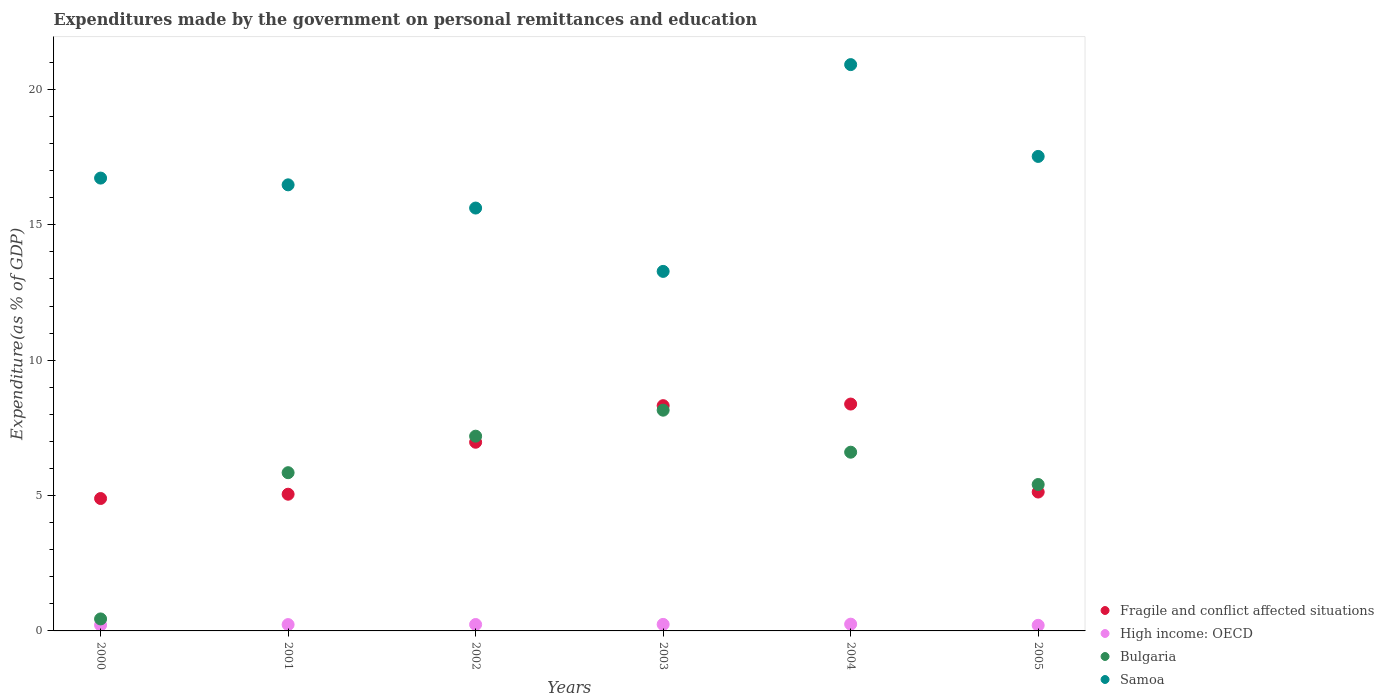Is the number of dotlines equal to the number of legend labels?
Make the answer very short. Yes. What is the expenditures made by the government on personal remittances and education in High income: OECD in 2001?
Ensure brevity in your answer.  0.23. Across all years, what is the maximum expenditures made by the government on personal remittances and education in Samoa?
Make the answer very short. 20.92. Across all years, what is the minimum expenditures made by the government on personal remittances and education in Samoa?
Your response must be concise. 13.28. In which year was the expenditures made by the government on personal remittances and education in High income: OECD maximum?
Ensure brevity in your answer.  2004. In which year was the expenditures made by the government on personal remittances and education in Bulgaria minimum?
Make the answer very short. 2000. What is the total expenditures made by the government on personal remittances and education in Bulgaria in the graph?
Offer a terse response. 33.65. What is the difference between the expenditures made by the government on personal remittances and education in Bulgaria in 2000 and that in 2005?
Your answer should be very brief. -4.97. What is the difference between the expenditures made by the government on personal remittances and education in Samoa in 2004 and the expenditures made by the government on personal remittances and education in High income: OECD in 2005?
Provide a succinct answer. 20.71. What is the average expenditures made by the government on personal remittances and education in Fragile and conflict affected situations per year?
Provide a short and direct response. 6.46. In the year 2000, what is the difference between the expenditures made by the government on personal remittances and education in Bulgaria and expenditures made by the government on personal remittances and education in High income: OECD?
Keep it short and to the point. 0.23. In how many years, is the expenditures made by the government on personal remittances and education in Samoa greater than 17 %?
Offer a very short reply. 2. What is the ratio of the expenditures made by the government on personal remittances and education in Samoa in 2001 to that in 2004?
Your answer should be compact. 0.79. Is the difference between the expenditures made by the government on personal remittances and education in Bulgaria in 2003 and 2005 greater than the difference between the expenditures made by the government on personal remittances and education in High income: OECD in 2003 and 2005?
Keep it short and to the point. Yes. What is the difference between the highest and the second highest expenditures made by the government on personal remittances and education in High income: OECD?
Give a very brief answer. 0.01. What is the difference between the highest and the lowest expenditures made by the government on personal remittances and education in High income: OECD?
Provide a short and direct response. 0.04. In how many years, is the expenditures made by the government on personal remittances and education in High income: OECD greater than the average expenditures made by the government on personal remittances and education in High income: OECD taken over all years?
Your answer should be compact. 4. Is the sum of the expenditures made by the government on personal remittances and education in Fragile and conflict affected situations in 2000 and 2002 greater than the maximum expenditures made by the government on personal remittances and education in Bulgaria across all years?
Ensure brevity in your answer.  Yes. Is it the case that in every year, the sum of the expenditures made by the government on personal remittances and education in High income: OECD and expenditures made by the government on personal remittances and education in Bulgaria  is greater than the expenditures made by the government on personal remittances and education in Samoa?
Make the answer very short. No. Is the expenditures made by the government on personal remittances and education in Samoa strictly less than the expenditures made by the government on personal remittances and education in Fragile and conflict affected situations over the years?
Provide a succinct answer. No. How many years are there in the graph?
Keep it short and to the point. 6. Are the values on the major ticks of Y-axis written in scientific E-notation?
Provide a short and direct response. No. Does the graph contain any zero values?
Your answer should be very brief. No. Does the graph contain grids?
Give a very brief answer. No. How many legend labels are there?
Provide a short and direct response. 4. What is the title of the graph?
Offer a terse response. Expenditures made by the government on personal remittances and education. What is the label or title of the Y-axis?
Provide a succinct answer. Expenditure(as % of GDP). What is the Expenditure(as % of GDP) of Fragile and conflict affected situations in 2000?
Provide a succinct answer. 4.89. What is the Expenditure(as % of GDP) in High income: OECD in 2000?
Your answer should be compact. 0.22. What is the Expenditure(as % of GDP) in Bulgaria in 2000?
Your answer should be compact. 0.44. What is the Expenditure(as % of GDP) of Samoa in 2000?
Your answer should be compact. 16.73. What is the Expenditure(as % of GDP) in Fragile and conflict affected situations in 2001?
Offer a very short reply. 5.05. What is the Expenditure(as % of GDP) of High income: OECD in 2001?
Provide a succinct answer. 0.23. What is the Expenditure(as % of GDP) of Bulgaria in 2001?
Provide a short and direct response. 5.84. What is the Expenditure(as % of GDP) of Samoa in 2001?
Offer a very short reply. 16.48. What is the Expenditure(as % of GDP) in Fragile and conflict affected situations in 2002?
Ensure brevity in your answer.  6.97. What is the Expenditure(as % of GDP) in High income: OECD in 2002?
Make the answer very short. 0.24. What is the Expenditure(as % of GDP) in Bulgaria in 2002?
Provide a short and direct response. 7.19. What is the Expenditure(as % of GDP) in Samoa in 2002?
Your response must be concise. 15.62. What is the Expenditure(as % of GDP) in Fragile and conflict affected situations in 2003?
Offer a terse response. 8.32. What is the Expenditure(as % of GDP) of High income: OECD in 2003?
Offer a very short reply. 0.24. What is the Expenditure(as % of GDP) in Bulgaria in 2003?
Give a very brief answer. 8.15. What is the Expenditure(as % of GDP) in Samoa in 2003?
Provide a short and direct response. 13.28. What is the Expenditure(as % of GDP) in Fragile and conflict affected situations in 2004?
Provide a short and direct response. 8.38. What is the Expenditure(as % of GDP) in High income: OECD in 2004?
Give a very brief answer. 0.25. What is the Expenditure(as % of GDP) in Bulgaria in 2004?
Keep it short and to the point. 6.6. What is the Expenditure(as % of GDP) of Samoa in 2004?
Your response must be concise. 20.92. What is the Expenditure(as % of GDP) in Fragile and conflict affected situations in 2005?
Keep it short and to the point. 5.13. What is the Expenditure(as % of GDP) in High income: OECD in 2005?
Your answer should be compact. 0.21. What is the Expenditure(as % of GDP) in Bulgaria in 2005?
Your response must be concise. 5.41. What is the Expenditure(as % of GDP) of Samoa in 2005?
Your answer should be very brief. 17.53. Across all years, what is the maximum Expenditure(as % of GDP) of Fragile and conflict affected situations?
Give a very brief answer. 8.38. Across all years, what is the maximum Expenditure(as % of GDP) of High income: OECD?
Give a very brief answer. 0.25. Across all years, what is the maximum Expenditure(as % of GDP) of Bulgaria?
Ensure brevity in your answer.  8.15. Across all years, what is the maximum Expenditure(as % of GDP) of Samoa?
Provide a succinct answer. 20.92. Across all years, what is the minimum Expenditure(as % of GDP) of Fragile and conflict affected situations?
Your answer should be very brief. 4.89. Across all years, what is the minimum Expenditure(as % of GDP) in High income: OECD?
Make the answer very short. 0.21. Across all years, what is the minimum Expenditure(as % of GDP) of Bulgaria?
Keep it short and to the point. 0.44. Across all years, what is the minimum Expenditure(as % of GDP) of Samoa?
Ensure brevity in your answer.  13.28. What is the total Expenditure(as % of GDP) of Fragile and conflict affected situations in the graph?
Your answer should be very brief. 38.74. What is the total Expenditure(as % of GDP) of High income: OECD in the graph?
Give a very brief answer. 1.38. What is the total Expenditure(as % of GDP) in Bulgaria in the graph?
Your answer should be compact. 33.65. What is the total Expenditure(as % of GDP) in Samoa in the graph?
Offer a very short reply. 100.55. What is the difference between the Expenditure(as % of GDP) of Fragile and conflict affected situations in 2000 and that in 2001?
Offer a very short reply. -0.16. What is the difference between the Expenditure(as % of GDP) of High income: OECD in 2000 and that in 2001?
Your answer should be compact. -0.02. What is the difference between the Expenditure(as % of GDP) of Bulgaria in 2000 and that in 2001?
Keep it short and to the point. -5.4. What is the difference between the Expenditure(as % of GDP) in Samoa in 2000 and that in 2001?
Offer a terse response. 0.25. What is the difference between the Expenditure(as % of GDP) of Fragile and conflict affected situations in 2000 and that in 2002?
Your answer should be compact. -2.08. What is the difference between the Expenditure(as % of GDP) in High income: OECD in 2000 and that in 2002?
Your answer should be very brief. -0.02. What is the difference between the Expenditure(as % of GDP) of Bulgaria in 2000 and that in 2002?
Your answer should be compact. -6.75. What is the difference between the Expenditure(as % of GDP) in Samoa in 2000 and that in 2002?
Keep it short and to the point. 1.11. What is the difference between the Expenditure(as % of GDP) of Fragile and conflict affected situations in 2000 and that in 2003?
Offer a terse response. -3.43. What is the difference between the Expenditure(as % of GDP) of High income: OECD in 2000 and that in 2003?
Ensure brevity in your answer.  -0.03. What is the difference between the Expenditure(as % of GDP) in Bulgaria in 2000 and that in 2003?
Provide a succinct answer. -7.71. What is the difference between the Expenditure(as % of GDP) of Samoa in 2000 and that in 2003?
Provide a succinct answer. 3.45. What is the difference between the Expenditure(as % of GDP) in Fragile and conflict affected situations in 2000 and that in 2004?
Keep it short and to the point. -3.49. What is the difference between the Expenditure(as % of GDP) in High income: OECD in 2000 and that in 2004?
Your response must be concise. -0.03. What is the difference between the Expenditure(as % of GDP) in Bulgaria in 2000 and that in 2004?
Your answer should be compact. -6.16. What is the difference between the Expenditure(as % of GDP) of Samoa in 2000 and that in 2004?
Provide a succinct answer. -4.19. What is the difference between the Expenditure(as % of GDP) in Fragile and conflict affected situations in 2000 and that in 2005?
Your answer should be very brief. -0.24. What is the difference between the Expenditure(as % of GDP) of High income: OECD in 2000 and that in 2005?
Give a very brief answer. 0.01. What is the difference between the Expenditure(as % of GDP) of Bulgaria in 2000 and that in 2005?
Give a very brief answer. -4.97. What is the difference between the Expenditure(as % of GDP) of Samoa in 2000 and that in 2005?
Provide a succinct answer. -0.8. What is the difference between the Expenditure(as % of GDP) of Fragile and conflict affected situations in 2001 and that in 2002?
Offer a terse response. -1.92. What is the difference between the Expenditure(as % of GDP) of High income: OECD in 2001 and that in 2002?
Provide a succinct answer. -0. What is the difference between the Expenditure(as % of GDP) of Bulgaria in 2001 and that in 2002?
Offer a very short reply. -1.35. What is the difference between the Expenditure(as % of GDP) in Samoa in 2001 and that in 2002?
Make the answer very short. 0.86. What is the difference between the Expenditure(as % of GDP) of Fragile and conflict affected situations in 2001 and that in 2003?
Ensure brevity in your answer.  -3.27. What is the difference between the Expenditure(as % of GDP) in High income: OECD in 2001 and that in 2003?
Keep it short and to the point. -0.01. What is the difference between the Expenditure(as % of GDP) of Bulgaria in 2001 and that in 2003?
Give a very brief answer. -2.31. What is the difference between the Expenditure(as % of GDP) of Samoa in 2001 and that in 2003?
Your answer should be compact. 3.2. What is the difference between the Expenditure(as % of GDP) in Fragile and conflict affected situations in 2001 and that in 2004?
Give a very brief answer. -3.33. What is the difference between the Expenditure(as % of GDP) in High income: OECD in 2001 and that in 2004?
Give a very brief answer. -0.02. What is the difference between the Expenditure(as % of GDP) of Bulgaria in 2001 and that in 2004?
Your answer should be compact. -0.76. What is the difference between the Expenditure(as % of GDP) in Samoa in 2001 and that in 2004?
Your answer should be compact. -4.44. What is the difference between the Expenditure(as % of GDP) of Fragile and conflict affected situations in 2001 and that in 2005?
Offer a very short reply. -0.08. What is the difference between the Expenditure(as % of GDP) in High income: OECD in 2001 and that in 2005?
Ensure brevity in your answer.  0.03. What is the difference between the Expenditure(as % of GDP) of Bulgaria in 2001 and that in 2005?
Give a very brief answer. 0.44. What is the difference between the Expenditure(as % of GDP) in Samoa in 2001 and that in 2005?
Offer a terse response. -1.05. What is the difference between the Expenditure(as % of GDP) in Fragile and conflict affected situations in 2002 and that in 2003?
Make the answer very short. -1.35. What is the difference between the Expenditure(as % of GDP) of High income: OECD in 2002 and that in 2003?
Offer a very short reply. -0. What is the difference between the Expenditure(as % of GDP) in Bulgaria in 2002 and that in 2003?
Your response must be concise. -0.96. What is the difference between the Expenditure(as % of GDP) of Samoa in 2002 and that in 2003?
Your answer should be compact. 2.34. What is the difference between the Expenditure(as % of GDP) of Fragile and conflict affected situations in 2002 and that in 2004?
Provide a succinct answer. -1.41. What is the difference between the Expenditure(as % of GDP) in High income: OECD in 2002 and that in 2004?
Provide a succinct answer. -0.01. What is the difference between the Expenditure(as % of GDP) of Bulgaria in 2002 and that in 2004?
Keep it short and to the point. 0.59. What is the difference between the Expenditure(as % of GDP) in Samoa in 2002 and that in 2004?
Provide a succinct answer. -5.3. What is the difference between the Expenditure(as % of GDP) of Fragile and conflict affected situations in 2002 and that in 2005?
Keep it short and to the point. 1.84. What is the difference between the Expenditure(as % of GDP) in High income: OECD in 2002 and that in 2005?
Give a very brief answer. 0.03. What is the difference between the Expenditure(as % of GDP) in Bulgaria in 2002 and that in 2005?
Keep it short and to the point. 1.79. What is the difference between the Expenditure(as % of GDP) of Samoa in 2002 and that in 2005?
Ensure brevity in your answer.  -1.91. What is the difference between the Expenditure(as % of GDP) in Fragile and conflict affected situations in 2003 and that in 2004?
Keep it short and to the point. -0.06. What is the difference between the Expenditure(as % of GDP) in High income: OECD in 2003 and that in 2004?
Your response must be concise. -0.01. What is the difference between the Expenditure(as % of GDP) of Bulgaria in 2003 and that in 2004?
Offer a terse response. 1.55. What is the difference between the Expenditure(as % of GDP) of Samoa in 2003 and that in 2004?
Your answer should be very brief. -7.64. What is the difference between the Expenditure(as % of GDP) in Fragile and conflict affected situations in 2003 and that in 2005?
Keep it short and to the point. 3.19. What is the difference between the Expenditure(as % of GDP) in High income: OECD in 2003 and that in 2005?
Your answer should be compact. 0.03. What is the difference between the Expenditure(as % of GDP) of Bulgaria in 2003 and that in 2005?
Offer a very short reply. 2.75. What is the difference between the Expenditure(as % of GDP) of Samoa in 2003 and that in 2005?
Ensure brevity in your answer.  -4.25. What is the difference between the Expenditure(as % of GDP) in Fragile and conflict affected situations in 2004 and that in 2005?
Keep it short and to the point. 3.25. What is the difference between the Expenditure(as % of GDP) of High income: OECD in 2004 and that in 2005?
Provide a short and direct response. 0.04. What is the difference between the Expenditure(as % of GDP) in Bulgaria in 2004 and that in 2005?
Offer a very short reply. 1.19. What is the difference between the Expenditure(as % of GDP) in Samoa in 2004 and that in 2005?
Your answer should be very brief. 3.39. What is the difference between the Expenditure(as % of GDP) in Fragile and conflict affected situations in 2000 and the Expenditure(as % of GDP) in High income: OECD in 2001?
Give a very brief answer. 4.66. What is the difference between the Expenditure(as % of GDP) of Fragile and conflict affected situations in 2000 and the Expenditure(as % of GDP) of Bulgaria in 2001?
Give a very brief answer. -0.95. What is the difference between the Expenditure(as % of GDP) of Fragile and conflict affected situations in 2000 and the Expenditure(as % of GDP) of Samoa in 2001?
Provide a succinct answer. -11.59. What is the difference between the Expenditure(as % of GDP) of High income: OECD in 2000 and the Expenditure(as % of GDP) of Bulgaria in 2001?
Your response must be concise. -5.63. What is the difference between the Expenditure(as % of GDP) of High income: OECD in 2000 and the Expenditure(as % of GDP) of Samoa in 2001?
Offer a terse response. -16.26. What is the difference between the Expenditure(as % of GDP) of Bulgaria in 2000 and the Expenditure(as % of GDP) of Samoa in 2001?
Make the answer very short. -16.04. What is the difference between the Expenditure(as % of GDP) in Fragile and conflict affected situations in 2000 and the Expenditure(as % of GDP) in High income: OECD in 2002?
Ensure brevity in your answer.  4.65. What is the difference between the Expenditure(as % of GDP) in Fragile and conflict affected situations in 2000 and the Expenditure(as % of GDP) in Bulgaria in 2002?
Your response must be concise. -2.3. What is the difference between the Expenditure(as % of GDP) of Fragile and conflict affected situations in 2000 and the Expenditure(as % of GDP) of Samoa in 2002?
Give a very brief answer. -10.73. What is the difference between the Expenditure(as % of GDP) in High income: OECD in 2000 and the Expenditure(as % of GDP) in Bulgaria in 2002?
Your answer should be very brief. -6.98. What is the difference between the Expenditure(as % of GDP) in High income: OECD in 2000 and the Expenditure(as % of GDP) in Samoa in 2002?
Ensure brevity in your answer.  -15.41. What is the difference between the Expenditure(as % of GDP) of Bulgaria in 2000 and the Expenditure(as % of GDP) of Samoa in 2002?
Keep it short and to the point. -15.18. What is the difference between the Expenditure(as % of GDP) of Fragile and conflict affected situations in 2000 and the Expenditure(as % of GDP) of High income: OECD in 2003?
Ensure brevity in your answer.  4.65. What is the difference between the Expenditure(as % of GDP) in Fragile and conflict affected situations in 2000 and the Expenditure(as % of GDP) in Bulgaria in 2003?
Make the answer very short. -3.26. What is the difference between the Expenditure(as % of GDP) in Fragile and conflict affected situations in 2000 and the Expenditure(as % of GDP) in Samoa in 2003?
Keep it short and to the point. -8.39. What is the difference between the Expenditure(as % of GDP) in High income: OECD in 2000 and the Expenditure(as % of GDP) in Bulgaria in 2003?
Your answer should be compact. -7.94. What is the difference between the Expenditure(as % of GDP) in High income: OECD in 2000 and the Expenditure(as % of GDP) in Samoa in 2003?
Offer a very short reply. -13.07. What is the difference between the Expenditure(as % of GDP) in Bulgaria in 2000 and the Expenditure(as % of GDP) in Samoa in 2003?
Provide a succinct answer. -12.84. What is the difference between the Expenditure(as % of GDP) of Fragile and conflict affected situations in 2000 and the Expenditure(as % of GDP) of High income: OECD in 2004?
Provide a succinct answer. 4.64. What is the difference between the Expenditure(as % of GDP) of Fragile and conflict affected situations in 2000 and the Expenditure(as % of GDP) of Bulgaria in 2004?
Your response must be concise. -1.71. What is the difference between the Expenditure(as % of GDP) in Fragile and conflict affected situations in 2000 and the Expenditure(as % of GDP) in Samoa in 2004?
Your answer should be compact. -16.03. What is the difference between the Expenditure(as % of GDP) of High income: OECD in 2000 and the Expenditure(as % of GDP) of Bulgaria in 2004?
Keep it short and to the point. -6.39. What is the difference between the Expenditure(as % of GDP) in High income: OECD in 2000 and the Expenditure(as % of GDP) in Samoa in 2004?
Offer a terse response. -20.7. What is the difference between the Expenditure(as % of GDP) in Bulgaria in 2000 and the Expenditure(as % of GDP) in Samoa in 2004?
Your answer should be very brief. -20.48. What is the difference between the Expenditure(as % of GDP) of Fragile and conflict affected situations in 2000 and the Expenditure(as % of GDP) of High income: OECD in 2005?
Provide a succinct answer. 4.68. What is the difference between the Expenditure(as % of GDP) in Fragile and conflict affected situations in 2000 and the Expenditure(as % of GDP) in Bulgaria in 2005?
Your response must be concise. -0.52. What is the difference between the Expenditure(as % of GDP) in Fragile and conflict affected situations in 2000 and the Expenditure(as % of GDP) in Samoa in 2005?
Ensure brevity in your answer.  -12.64. What is the difference between the Expenditure(as % of GDP) of High income: OECD in 2000 and the Expenditure(as % of GDP) of Bulgaria in 2005?
Your answer should be very brief. -5.19. What is the difference between the Expenditure(as % of GDP) of High income: OECD in 2000 and the Expenditure(as % of GDP) of Samoa in 2005?
Make the answer very short. -17.31. What is the difference between the Expenditure(as % of GDP) in Bulgaria in 2000 and the Expenditure(as % of GDP) in Samoa in 2005?
Your response must be concise. -17.08. What is the difference between the Expenditure(as % of GDP) in Fragile and conflict affected situations in 2001 and the Expenditure(as % of GDP) in High income: OECD in 2002?
Ensure brevity in your answer.  4.81. What is the difference between the Expenditure(as % of GDP) of Fragile and conflict affected situations in 2001 and the Expenditure(as % of GDP) of Bulgaria in 2002?
Provide a succinct answer. -2.14. What is the difference between the Expenditure(as % of GDP) of Fragile and conflict affected situations in 2001 and the Expenditure(as % of GDP) of Samoa in 2002?
Give a very brief answer. -10.57. What is the difference between the Expenditure(as % of GDP) in High income: OECD in 2001 and the Expenditure(as % of GDP) in Bulgaria in 2002?
Offer a terse response. -6.96. What is the difference between the Expenditure(as % of GDP) of High income: OECD in 2001 and the Expenditure(as % of GDP) of Samoa in 2002?
Offer a terse response. -15.39. What is the difference between the Expenditure(as % of GDP) of Bulgaria in 2001 and the Expenditure(as % of GDP) of Samoa in 2002?
Provide a succinct answer. -9.78. What is the difference between the Expenditure(as % of GDP) of Fragile and conflict affected situations in 2001 and the Expenditure(as % of GDP) of High income: OECD in 2003?
Your answer should be compact. 4.81. What is the difference between the Expenditure(as % of GDP) of Fragile and conflict affected situations in 2001 and the Expenditure(as % of GDP) of Bulgaria in 2003?
Ensure brevity in your answer.  -3.1. What is the difference between the Expenditure(as % of GDP) in Fragile and conflict affected situations in 2001 and the Expenditure(as % of GDP) in Samoa in 2003?
Your response must be concise. -8.23. What is the difference between the Expenditure(as % of GDP) of High income: OECD in 2001 and the Expenditure(as % of GDP) of Bulgaria in 2003?
Keep it short and to the point. -7.92. What is the difference between the Expenditure(as % of GDP) in High income: OECD in 2001 and the Expenditure(as % of GDP) in Samoa in 2003?
Your answer should be very brief. -13.05. What is the difference between the Expenditure(as % of GDP) of Bulgaria in 2001 and the Expenditure(as % of GDP) of Samoa in 2003?
Offer a terse response. -7.44. What is the difference between the Expenditure(as % of GDP) of Fragile and conflict affected situations in 2001 and the Expenditure(as % of GDP) of High income: OECD in 2004?
Provide a short and direct response. 4.8. What is the difference between the Expenditure(as % of GDP) in Fragile and conflict affected situations in 2001 and the Expenditure(as % of GDP) in Bulgaria in 2004?
Ensure brevity in your answer.  -1.55. What is the difference between the Expenditure(as % of GDP) in Fragile and conflict affected situations in 2001 and the Expenditure(as % of GDP) in Samoa in 2004?
Your answer should be compact. -15.87. What is the difference between the Expenditure(as % of GDP) of High income: OECD in 2001 and the Expenditure(as % of GDP) of Bulgaria in 2004?
Your response must be concise. -6.37. What is the difference between the Expenditure(as % of GDP) in High income: OECD in 2001 and the Expenditure(as % of GDP) in Samoa in 2004?
Provide a succinct answer. -20.68. What is the difference between the Expenditure(as % of GDP) in Bulgaria in 2001 and the Expenditure(as % of GDP) in Samoa in 2004?
Offer a terse response. -15.07. What is the difference between the Expenditure(as % of GDP) of Fragile and conflict affected situations in 2001 and the Expenditure(as % of GDP) of High income: OECD in 2005?
Your answer should be compact. 4.84. What is the difference between the Expenditure(as % of GDP) of Fragile and conflict affected situations in 2001 and the Expenditure(as % of GDP) of Bulgaria in 2005?
Your answer should be very brief. -0.36. What is the difference between the Expenditure(as % of GDP) in Fragile and conflict affected situations in 2001 and the Expenditure(as % of GDP) in Samoa in 2005?
Your response must be concise. -12.48. What is the difference between the Expenditure(as % of GDP) in High income: OECD in 2001 and the Expenditure(as % of GDP) in Bulgaria in 2005?
Offer a very short reply. -5.17. What is the difference between the Expenditure(as % of GDP) in High income: OECD in 2001 and the Expenditure(as % of GDP) in Samoa in 2005?
Offer a very short reply. -17.29. What is the difference between the Expenditure(as % of GDP) of Bulgaria in 2001 and the Expenditure(as % of GDP) of Samoa in 2005?
Give a very brief answer. -11.68. What is the difference between the Expenditure(as % of GDP) of Fragile and conflict affected situations in 2002 and the Expenditure(as % of GDP) of High income: OECD in 2003?
Make the answer very short. 6.73. What is the difference between the Expenditure(as % of GDP) in Fragile and conflict affected situations in 2002 and the Expenditure(as % of GDP) in Bulgaria in 2003?
Provide a succinct answer. -1.18. What is the difference between the Expenditure(as % of GDP) in Fragile and conflict affected situations in 2002 and the Expenditure(as % of GDP) in Samoa in 2003?
Provide a succinct answer. -6.31. What is the difference between the Expenditure(as % of GDP) in High income: OECD in 2002 and the Expenditure(as % of GDP) in Bulgaria in 2003?
Provide a short and direct response. -7.92. What is the difference between the Expenditure(as % of GDP) of High income: OECD in 2002 and the Expenditure(as % of GDP) of Samoa in 2003?
Provide a short and direct response. -13.04. What is the difference between the Expenditure(as % of GDP) of Bulgaria in 2002 and the Expenditure(as % of GDP) of Samoa in 2003?
Your answer should be compact. -6.09. What is the difference between the Expenditure(as % of GDP) of Fragile and conflict affected situations in 2002 and the Expenditure(as % of GDP) of High income: OECD in 2004?
Provide a succinct answer. 6.72. What is the difference between the Expenditure(as % of GDP) of Fragile and conflict affected situations in 2002 and the Expenditure(as % of GDP) of Bulgaria in 2004?
Provide a short and direct response. 0.37. What is the difference between the Expenditure(as % of GDP) of Fragile and conflict affected situations in 2002 and the Expenditure(as % of GDP) of Samoa in 2004?
Your answer should be very brief. -13.95. What is the difference between the Expenditure(as % of GDP) of High income: OECD in 2002 and the Expenditure(as % of GDP) of Bulgaria in 2004?
Provide a succinct answer. -6.37. What is the difference between the Expenditure(as % of GDP) in High income: OECD in 2002 and the Expenditure(as % of GDP) in Samoa in 2004?
Your response must be concise. -20.68. What is the difference between the Expenditure(as % of GDP) in Bulgaria in 2002 and the Expenditure(as % of GDP) in Samoa in 2004?
Offer a very short reply. -13.73. What is the difference between the Expenditure(as % of GDP) of Fragile and conflict affected situations in 2002 and the Expenditure(as % of GDP) of High income: OECD in 2005?
Make the answer very short. 6.76. What is the difference between the Expenditure(as % of GDP) in Fragile and conflict affected situations in 2002 and the Expenditure(as % of GDP) in Bulgaria in 2005?
Give a very brief answer. 1.56. What is the difference between the Expenditure(as % of GDP) of Fragile and conflict affected situations in 2002 and the Expenditure(as % of GDP) of Samoa in 2005?
Offer a terse response. -10.56. What is the difference between the Expenditure(as % of GDP) in High income: OECD in 2002 and the Expenditure(as % of GDP) in Bulgaria in 2005?
Offer a terse response. -5.17. What is the difference between the Expenditure(as % of GDP) in High income: OECD in 2002 and the Expenditure(as % of GDP) in Samoa in 2005?
Offer a very short reply. -17.29. What is the difference between the Expenditure(as % of GDP) of Bulgaria in 2002 and the Expenditure(as % of GDP) of Samoa in 2005?
Your answer should be very brief. -10.33. What is the difference between the Expenditure(as % of GDP) of Fragile and conflict affected situations in 2003 and the Expenditure(as % of GDP) of High income: OECD in 2004?
Provide a succinct answer. 8.07. What is the difference between the Expenditure(as % of GDP) of Fragile and conflict affected situations in 2003 and the Expenditure(as % of GDP) of Bulgaria in 2004?
Your response must be concise. 1.72. What is the difference between the Expenditure(as % of GDP) in Fragile and conflict affected situations in 2003 and the Expenditure(as % of GDP) in Samoa in 2004?
Ensure brevity in your answer.  -12.6. What is the difference between the Expenditure(as % of GDP) in High income: OECD in 2003 and the Expenditure(as % of GDP) in Bulgaria in 2004?
Ensure brevity in your answer.  -6.36. What is the difference between the Expenditure(as % of GDP) of High income: OECD in 2003 and the Expenditure(as % of GDP) of Samoa in 2004?
Ensure brevity in your answer.  -20.68. What is the difference between the Expenditure(as % of GDP) in Bulgaria in 2003 and the Expenditure(as % of GDP) in Samoa in 2004?
Provide a short and direct response. -12.77. What is the difference between the Expenditure(as % of GDP) of Fragile and conflict affected situations in 2003 and the Expenditure(as % of GDP) of High income: OECD in 2005?
Your answer should be compact. 8.11. What is the difference between the Expenditure(as % of GDP) of Fragile and conflict affected situations in 2003 and the Expenditure(as % of GDP) of Bulgaria in 2005?
Make the answer very short. 2.91. What is the difference between the Expenditure(as % of GDP) in Fragile and conflict affected situations in 2003 and the Expenditure(as % of GDP) in Samoa in 2005?
Keep it short and to the point. -9.21. What is the difference between the Expenditure(as % of GDP) in High income: OECD in 2003 and the Expenditure(as % of GDP) in Bulgaria in 2005?
Your response must be concise. -5.17. What is the difference between the Expenditure(as % of GDP) in High income: OECD in 2003 and the Expenditure(as % of GDP) in Samoa in 2005?
Your response must be concise. -17.29. What is the difference between the Expenditure(as % of GDP) in Bulgaria in 2003 and the Expenditure(as % of GDP) in Samoa in 2005?
Offer a terse response. -9.37. What is the difference between the Expenditure(as % of GDP) in Fragile and conflict affected situations in 2004 and the Expenditure(as % of GDP) in High income: OECD in 2005?
Provide a short and direct response. 8.17. What is the difference between the Expenditure(as % of GDP) of Fragile and conflict affected situations in 2004 and the Expenditure(as % of GDP) of Bulgaria in 2005?
Provide a short and direct response. 2.97. What is the difference between the Expenditure(as % of GDP) of Fragile and conflict affected situations in 2004 and the Expenditure(as % of GDP) of Samoa in 2005?
Make the answer very short. -9.15. What is the difference between the Expenditure(as % of GDP) of High income: OECD in 2004 and the Expenditure(as % of GDP) of Bulgaria in 2005?
Your response must be concise. -5.16. What is the difference between the Expenditure(as % of GDP) of High income: OECD in 2004 and the Expenditure(as % of GDP) of Samoa in 2005?
Your response must be concise. -17.28. What is the difference between the Expenditure(as % of GDP) of Bulgaria in 2004 and the Expenditure(as % of GDP) of Samoa in 2005?
Make the answer very short. -10.93. What is the average Expenditure(as % of GDP) of Fragile and conflict affected situations per year?
Make the answer very short. 6.46. What is the average Expenditure(as % of GDP) of High income: OECD per year?
Ensure brevity in your answer.  0.23. What is the average Expenditure(as % of GDP) in Bulgaria per year?
Give a very brief answer. 5.61. What is the average Expenditure(as % of GDP) of Samoa per year?
Keep it short and to the point. 16.76. In the year 2000, what is the difference between the Expenditure(as % of GDP) in Fragile and conflict affected situations and Expenditure(as % of GDP) in High income: OECD?
Offer a very short reply. 4.68. In the year 2000, what is the difference between the Expenditure(as % of GDP) in Fragile and conflict affected situations and Expenditure(as % of GDP) in Bulgaria?
Your response must be concise. 4.45. In the year 2000, what is the difference between the Expenditure(as % of GDP) of Fragile and conflict affected situations and Expenditure(as % of GDP) of Samoa?
Make the answer very short. -11.84. In the year 2000, what is the difference between the Expenditure(as % of GDP) of High income: OECD and Expenditure(as % of GDP) of Bulgaria?
Your answer should be very brief. -0.23. In the year 2000, what is the difference between the Expenditure(as % of GDP) in High income: OECD and Expenditure(as % of GDP) in Samoa?
Give a very brief answer. -16.51. In the year 2000, what is the difference between the Expenditure(as % of GDP) in Bulgaria and Expenditure(as % of GDP) in Samoa?
Your response must be concise. -16.28. In the year 2001, what is the difference between the Expenditure(as % of GDP) in Fragile and conflict affected situations and Expenditure(as % of GDP) in High income: OECD?
Provide a short and direct response. 4.82. In the year 2001, what is the difference between the Expenditure(as % of GDP) in Fragile and conflict affected situations and Expenditure(as % of GDP) in Bulgaria?
Your answer should be compact. -0.8. In the year 2001, what is the difference between the Expenditure(as % of GDP) of Fragile and conflict affected situations and Expenditure(as % of GDP) of Samoa?
Your response must be concise. -11.43. In the year 2001, what is the difference between the Expenditure(as % of GDP) in High income: OECD and Expenditure(as % of GDP) in Bulgaria?
Your answer should be compact. -5.61. In the year 2001, what is the difference between the Expenditure(as % of GDP) of High income: OECD and Expenditure(as % of GDP) of Samoa?
Provide a short and direct response. -16.24. In the year 2001, what is the difference between the Expenditure(as % of GDP) in Bulgaria and Expenditure(as % of GDP) in Samoa?
Your response must be concise. -10.63. In the year 2002, what is the difference between the Expenditure(as % of GDP) of Fragile and conflict affected situations and Expenditure(as % of GDP) of High income: OECD?
Your answer should be very brief. 6.73. In the year 2002, what is the difference between the Expenditure(as % of GDP) in Fragile and conflict affected situations and Expenditure(as % of GDP) in Bulgaria?
Your answer should be very brief. -0.22. In the year 2002, what is the difference between the Expenditure(as % of GDP) in Fragile and conflict affected situations and Expenditure(as % of GDP) in Samoa?
Your answer should be compact. -8.65. In the year 2002, what is the difference between the Expenditure(as % of GDP) in High income: OECD and Expenditure(as % of GDP) in Bulgaria?
Keep it short and to the point. -6.96. In the year 2002, what is the difference between the Expenditure(as % of GDP) in High income: OECD and Expenditure(as % of GDP) in Samoa?
Offer a very short reply. -15.38. In the year 2002, what is the difference between the Expenditure(as % of GDP) of Bulgaria and Expenditure(as % of GDP) of Samoa?
Your answer should be compact. -8.43. In the year 2003, what is the difference between the Expenditure(as % of GDP) in Fragile and conflict affected situations and Expenditure(as % of GDP) in High income: OECD?
Ensure brevity in your answer.  8.08. In the year 2003, what is the difference between the Expenditure(as % of GDP) of Fragile and conflict affected situations and Expenditure(as % of GDP) of Bulgaria?
Provide a short and direct response. 0.17. In the year 2003, what is the difference between the Expenditure(as % of GDP) of Fragile and conflict affected situations and Expenditure(as % of GDP) of Samoa?
Offer a terse response. -4.96. In the year 2003, what is the difference between the Expenditure(as % of GDP) of High income: OECD and Expenditure(as % of GDP) of Bulgaria?
Provide a succinct answer. -7.91. In the year 2003, what is the difference between the Expenditure(as % of GDP) in High income: OECD and Expenditure(as % of GDP) in Samoa?
Your answer should be very brief. -13.04. In the year 2003, what is the difference between the Expenditure(as % of GDP) in Bulgaria and Expenditure(as % of GDP) in Samoa?
Give a very brief answer. -5.13. In the year 2004, what is the difference between the Expenditure(as % of GDP) in Fragile and conflict affected situations and Expenditure(as % of GDP) in High income: OECD?
Offer a very short reply. 8.13. In the year 2004, what is the difference between the Expenditure(as % of GDP) of Fragile and conflict affected situations and Expenditure(as % of GDP) of Bulgaria?
Your answer should be very brief. 1.78. In the year 2004, what is the difference between the Expenditure(as % of GDP) of Fragile and conflict affected situations and Expenditure(as % of GDP) of Samoa?
Your response must be concise. -12.54. In the year 2004, what is the difference between the Expenditure(as % of GDP) in High income: OECD and Expenditure(as % of GDP) in Bulgaria?
Your answer should be very brief. -6.35. In the year 2004, what is the difference between the Expenditure(as % of GDP) in High income: OECD and Expenditure(as % of GDP) in Samoa?
Keep it short and to the point. -20.67. In the year 2004, what is the difference between the Expenditure(as % of GDP) in Bulgaria and Expenditure(as % of GDP) in Samoa?
Your answer should be very brief. -14.32. In the year 2005, what is the difference between the Expenditure(as % of GDP) in Fragile and conflict affected situations and Expenditure(as % of GDP) in High income: OECD?
Ensure brevity in your answer.  4.92. In the year 2005, what is the difference between the Expenditure(as % of GDP) of Fragile and conflict affected situations and Expenditure(as % of GDP) of Bulgaria?
Your response must be concise. -0.28. In the year 2005, what is the difference between the Expenditure(as % of GDP) of Fragile and conflict affected situations and Expenditure(as % of GDP) of Samoa?
Offer a terse response. -12.4. In the year 2005, what is the difference between the Expenditure(as % of GDP) of High income: OECD and Expenditure(as % of GDP) of Bulgaria?
Provide a succinct answer. -5.2. In the year 2005, what is the difference between the Expenditure(as % of GDP) of High income: OECD and Expenditure(as % of GDP) of Samoa?
Make the answer very short. -17.32. In the year 2005, what is the difference between the Expenditure(as % of GDP) of Bulgaria and Expenditure(as % of GDP) of Samoa?
Your answer should be very brief. -12.12. What is the ratio of the Expenditure(as % of GDP) in Fragile and conflict affected situations in 2000 to that in 2001?
Keep it short and to the point. 0.97. What is the ratio of the Expenditure(as % of GDP) of High income: OECD in 2000 to that in 2001?
Your answer should be very brief. 0.92. What is the ratio of the Expenditure(as % of GDP) of Bulgaria in 2000 to that in 2001?
Provide a short and direct response. 0.08. What is the ratio of the Expenditure(as % of GDP) of Samoa in 2000 to that in 2001?
Provide a short and direct response. 1.02. What is the ratio of the Expenditure(as % of GDP) of Fragile and conflict affected situations in 2000 to that in 2002?
Your answer should be compact. 0.7. What is the ratio of the Expenditure(as % of GDP) in High income: OECD in 2000 to that in 2002?
Make the answer very short. 0.91. What is the ratio of the Expenditure(as % of GDP) in Bulgaria in 2000 to that in 2002?
Ensure brevity in your answer.  0.06. What is the ratio of the Expenditure(as % of GDP) in Samoa in 2000 to that in 2002?
Give a very brief answer. 1.07. What is the ratio of the Expenditure(as % of GDP) in Fragile and conflict affected situations in 2000 to that in 2003?
Give a very brief answer. 0.59. What is the ratio of the Expenditure(as % of GDP) in High income: OECD in 2000 to that in 2003?
Your response must be concise. 0.89. What is the ratio of the Expenditure(as % of GDP) of Bulgaria in 2000 to that in 2003?
Your answer should be compact. 0.05. What is the ratio of the Expenditure(as % of GDP) of Samoa in 2000 to that in 2003?
Keep it short and to the point. 1.26. What is the ratio of the Expenditure(as % of GDP) of Fragile and conflict affected situations in 2000 to that in 2004?
Ensure brevity in your answer.  0.58. What is the ratio of the Expenditure(as % of GDP) in High income: OECD in 2000 to that in 2004?
Give a very brief answer. 0.86. What is the ratio of the Expenditure(as % of GDP) of Bulgaria in 2000 to that in 2004?
Your answer should be very brief. 0.07. What is the ratio of the Expenditure(as % of GDP) in Samoa in 2000 to that in 2004?
Give a very brief answer. 0.8. What is the ratio of the Expenditure(as % of GDP) of Fragile and conflict affected situations in 2000 to that in 2005?
Give a very brief answer. 0.95. What is the ratio of the Expenditure(as % of GDP) of High income: OECD in 2000 to that in 2005?
Your answer should be very brief. 1.04. What is the ratio of the Expenditure(as % of GDP) of Bulgaria in 2000 to that in 2005?
Offer a very short reply. 0.08. What is the ratio of the Expenditure(as % of GDP) in Samoa in 2000 to that in 2005?
Ensure brevity in your answer.  0.95. What is the ratio of the Expenditure(as % of GDP) in Fragile and conflict affected situations in 2001 to that in 2002?
Your response must be concise. 0.72. What is the ratio of the Expenditure(as % of GDP) of Bulgaria in 2001 to that in 2002?
Offer a terse response. 0.81. What is the ratio of the Expenditure(as % of GDP) in Samoa in 2001 to that in 2002?
Ensure brevity in your answer.  1.05. What is the ratio of the Expenditure(as % of GDP) of Fragile and conflict affected situations in 2001 to that in 2003?
Provide a succinct answer. 0.61. What is the ratio of the Expenditure(as % of GDP) of High income: OECD in 2001 to that in 2003?
Your answer should be compact. 0.97. What is the ratio of the Expenditure(as % of GDP) in Bulgaria in 2001 to that in 2003?
Your answer should be very brief. 0.72. What is the ratio of the Expenditure(as % of GDP) in Samoa in 2001 to that in 2003?
Make the answer very short. 1.24. What is the ratio of the Expenditure(as % of GDP) of Fragile and conflict affected situations in 2001 to that in 2004?
Give a very brief answer. 0.6. What is the ratio of the Expenditure(as % of GDP) of High income: OECD in 2001 to that in 2004?
Give a very brief answer. 0.94. What is the ratio of the Expenditure(as % of GDP) of Bulgaria in 2001 to that in 2004?
Give a very brief answer. 0.89. What is the ratio of the Expenditure(as % of GDP) of Samoa in 2001 to that in 2004?
Provide a succinct answer. 0.79. What is the ratio of the Expenditure(as % of GDP) of Fragile and conflict affected situations in 2001 to that in 2005?
Make the answer very short. 0.98. What is the ratio of the Expenditure(as % of GDP) in High income: OECD in 2001 to that in 2005?
Your answer should be very brief. 1.13. What is the ratio of the Expenditure(as % of GDP) of Bulgaria in 2001 to that in 2005?
Offer a terse response. 1.08. What is the ratio of the Expenditure(as % of GDP) of Samoa in 2001 to that in 2005?
Make the answer very short. 0.94. What is the ratio of the Expenditure(as % of GDP) of Fragile and conflict affected situations in 2002 to that in 2003?
Your answer should be very brief. 0.84. What is the ratio of the Expenditure(as % of GDP) of High income: OECD in 2002 to that in 2003?
Your answer should be very brief. 0.98. What is the ratio of the Expenditure(as % of GDP) in Bulgaria in 2002 to that in 2003?
Provide a short and direct response. 0.88. What is the ratio of the Expenditure(as % of GDP) in Samoa in 2002 to that in 2003?
Your answer should be compact. 1.18. What is the ratio of the Expenditure(as % of GDP) of Fragile and conflict affected situations in 2002 to that in 2004?
Provide a short and direct response. 0.83. What is the ratio of the Expenditure(as % of GDP) in High income: OECD in 2002 to that in 2004?
Ensure brevity in your answer.  0.95. What is the ratio of the Expenditure(as % of GDP) of Bulgaria in 2002 to that in 2004?
Keep it short and to the point. 1.09. What is the ratio of the Expenditure(as % of GDP) of Samoa in 2002 to that in 2004?
Keep it short and to the point. 0.75. What is the ratio of the Expenditure(as % of GDP) of Fragile and conflict affected situations in 2002 to that in 2005?
Offer a very short reply. 1.36. What is the ratio of the Expenditure(as % of GDP) in High income: OECD in 2002 to that in 2005?
Offer a very short reply. 1.15. What is the ratio of the Expenditure(as % of GDP) of Bulgaria in 2002 to that in 2005?
Provide a succinct answer. 1.33. What is the ratio of the Expenditure(as % of GDP) in Samoa in 2002 to that in 2005?
Your answer should be very brief. 0.89. What is the ratio of the Expenditure(as % of GDP) of High income: OECD in 2003 to that in 2004?
Keep it short and to the point. 0.97. What is the ratio of the Expenditure(as % of GDP) in Bulgaria in 2003 to that in 2004?
Offer a very short reply. 1.24. What is the ratio of the Expenditure(as % of GDP) in Samoa in 2003 to that in 2004?
Your answer should be very brief. 0.63. What is the ratio of the Expenditure(as % of GDP) in Fragile and conflict affected situations in 2003 to that in 2005?
Give a very brief answer. 1.62. What is the ratio of the Expenditure(as % of GDP) of High income: OECD in 2003 to that in 2005?
Ensure brevity in your answer.  1.17. What is the ratio of the Expenditure(as % of GDP) in Bulgaria in 2003 to that in 2005?
Offer a very short reply. 1.51. What is the ratio of the Expenditure(as % of GDP) in Samoa in 2003 to that in 2005?
Your answer should be very brief. 0.76. What is the ratio of the Expenditure(as % of GDP) of Fragile and conflict affected situations in 2004 to that in 2005?
Make the answer very short. 1.63. What is the ratio of the Expenditure(as % of GDP) of High income: OECD in 2004 to that in 2005?
Provide a short and direct response. 1.21. What is the ratio of the Expenditure(as % of GDP) of Bulgaria in 2004 to that in 2005?
Keep it short and to the point. 1.22. What is the ratio of the Expenditure(as % of GDP) of Samoa in 2004 to that in 2005?
Provide a short and direct response. 1.19. What is the difference between the highest and the second highest Expenditure(as % of GDP) of Fragile and conflict affected situations?
Offer a terse response. 0.06. What is the difference between the highest and the second highest Expenditure(as % of GDP) of High income: OECD?
Provide a short and direct response. 0.01. What is the difference between the highest and the second highest Expenditure(as % of GDP) of Bulgaria?
Your response must be concise. 0.96. What is the difference between the highest and the second highest Expenditure(as % of GDP) of Samoa?
Your answer should be compact. 3.39. What is the difference between the highest and the lowest Expenditure(as % of GDP) of Fragile and conflict affected situations?
Your answer should be compact. 3.49. What is the difference between the highest and the lowest Expenditure(as % of GDP) in High income: OECD?
Your response must be concise. 0.04. What is the difference between the highest and the lowest Expenditure(as % of GDP) in Bulgaria?
Your answer should be very brief. 7.71. What is the difference between the highest and the lowest Expenditure(as % of GDP) in Samoa?
Your response must be concise. 7.64. 